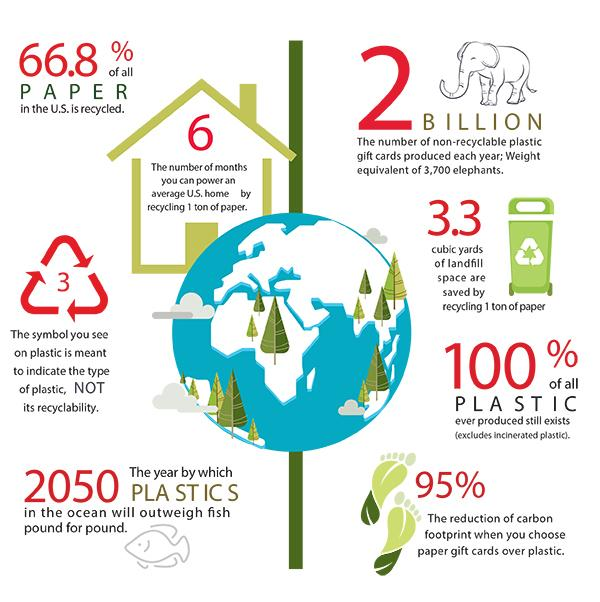Specify some key components in this picture. In the United States, only 33.2% of all paper is recycled, indicating that a significant portion of paper waste ends up in landfills and oceans. In the United States, approximately 2 billion non-recyclable plastic gift cards are produced annually. 